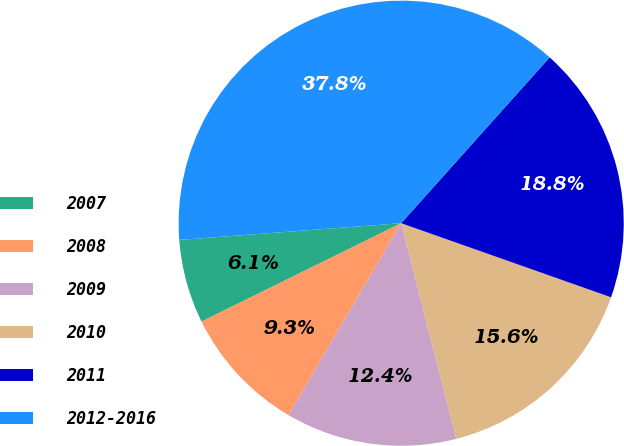Convert chart to OTSL. <chart><loc_0><loc_0><loc_500><loc_500><pie_chart><fcel>2007<fcel>2008<fcel>2009<fcel>2010<fcel>2011<fcel>2012-2016<nl><fcel>6.09%<fcel>9.26%<fcel>12.44%<fcel>15.61%<fcel>18.78%<fcel>37.82%<nl></chart> 